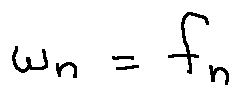Convert formula to latex. <formula><loc_0><loc_0><loc_500><loc_500>w _ { n } = f _ { n }</formula> 